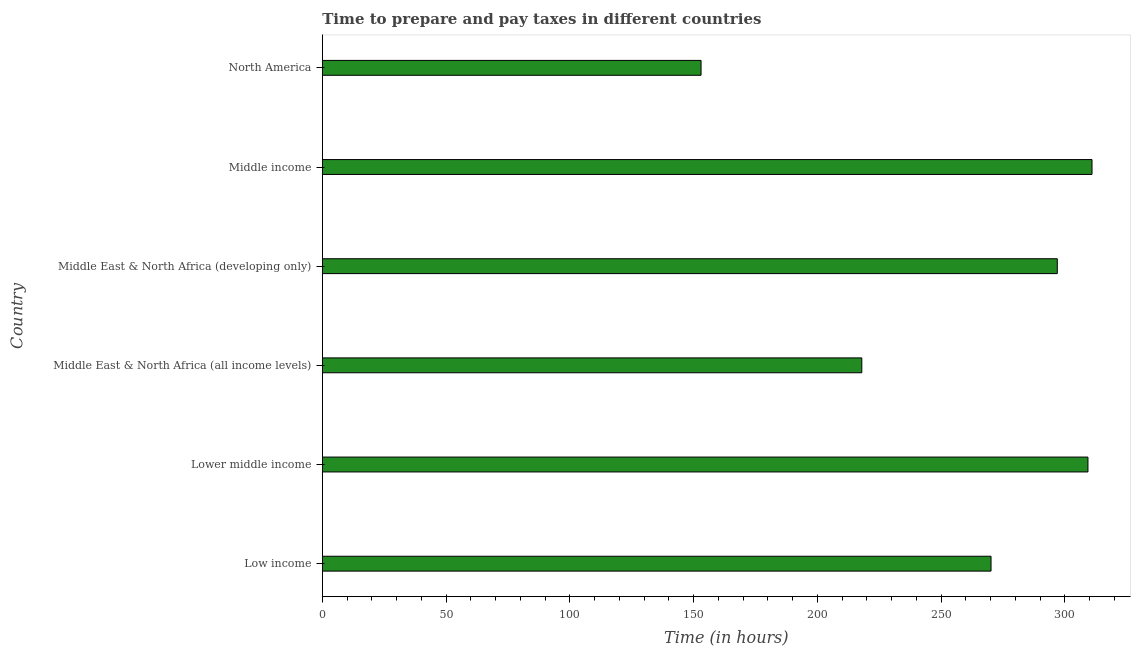What is the title of the graph?
Provide a short and direct response. Time to prepare and pay taxes in different countries. What is the label or title of the X-axis?
Ensure brevity in your answer.  Time (in hours). What is the time to prepare and pay taxes in Lower middle income?
Offer a terse response. 309.31. Across all countries, what is the maximum time to prepare and pay taxes?
Make the answer very short. 310.95. Across all countries, what is the minimum time to prepare and pay taxes?
Your answer should be compact. 153. What is the sum of the time to prepare and pay taxes?
Offer a terse response. 1558.29. What is the difference between the time to prepare and pay taxes in Lower middle income and Middle East & North Africa (all income levels)?
Provide a short and direct response. 91.36. What is the average time to prepare and pay taxes per country?
Provide a succinct answer. 259.71. What is the median time to prepare and pay taxes?
Make the answer very short. 283.54. In how many countries, is the time to prepare and pay taxes greater than 210 hours?
Provide a short and direct response. 5. What is the ratio of the time to prepare and pay taxes in Lower middle income to that in Middle East & North Africa (developing only)?
Keep it short and to the point. 1.04. Is the time to prepare and pay taxes in Middle East & North Africa (all income levels) less than that in Middle income?
Provide a short and direct response. Yes. Is the difference between the time to prepare and pay taxes in Low income and Lower middle income greater than the difference between any two countries?
Your answer should be compact. No. What is the difference between the highest and the second highest time to prepare and pay taxes?
Ensure brevity in your answer.  1.64. Is the sum of the time to prepare and pay taxes in Middle East & North Africa (developing only) and North America greater than the maximum time to prepare and pay taxes across all countries?
Your response must be concise. Yes. What is the difference between the highest and the lowest time to prepare and pay taxes?
Give a very brief answer. 157.95. How many bars are there?
Your answer should be compact. 6. Are all the bars in the graph horizontal?
Offer a very short reply. Yes. What is the Time (in hours) in Low income?
Provide a short and direct response. 270.16. What is the Time (in hours) in Lower middle income?
Ensure brevity in your answer.  309.31. What is the Time (in hours) in Middle East & North Africa (all income levels)?
Give a very brief answer. 217.95. What is the Time (in hours) of Middle East & North Africa (developing only)?
Give a very brief answer. 296.92. What is the Time (in hours) of Middle income?
Your answer should be very brief. 310.95. What is the Time (in hours) in North America?
Offer a very short reply. 153. What is the difference between the Time (in hours) in Low income and Lower middle income?
Offer a terse response. -39.16. What is the difference between the Time (in hours) in Low income and Middle East & North Africa (all income levels)?
Your answer should be very brief. 52.2. What is the difference between the Time (in hours) in Low income and Middle East & North Africa (developing only)?
Your answer should be very brief. -26.77. What is the difference between the Time (in hours) in Low income and Middle income?
Make the answer very short. -40.79. What is the difference between the Time (in hours) in Low income and North America?
Your response must be concise. 117.16. What is the difference between the Time (in hours) in Lower middle income and Middle East & North Africa (all income levels)?
Provide a short and direct response. 91.36. What is the difference between the Time (in hours) in Lower middle income and Middle East & North Africa (developing only)?
Your response must be concise. 12.39. What is the difference between the Time (in hours) in Lower middle income and Middle income?
Offer a terse response. -1.64. What is the difference between the Time (in hours) in Lower middle income and North America?
Offer a terse response. 156.31. What is the difference between the Time (in hours) in Middle East & North Africa (all income levels) and Middle East & North Africa (developing only)?
Ensure brevity in your answer.  -78.97. What is the difference between the Time (in hours) in Middle East & North Africa (all income levels) and Middle income?
Offer a terse response. -93. What is the difference between the Time (in hours) in Middle East & North Africa (all income levels) and North America?
Your answer should be very brief. 64.95. What is the difference between the Time (in hours) in Middle East & North Africa (developing only) and Middle income?
Ensure brevity in your answer.  -14.03. What is the difference between the Time (in hours) in Middle East & North Africa (developing only) and North America?
Your answer should be very brief. 143.92. What is the difference between the Time (in hours) in Middle income and North America?
Give a very brief answer. 157.95. What is the ratio of the Time (in hours) in Low income to that in Lower middle income?
Make the answer very short. 0.87. What is the ratio of the Time (in hours) in Low income to that in Middle East & North Africa (all income levels)?
Provide a short and direct response. 1.24. What is the ratio of the Time (in hours) in Low income to that in Middle East & North Africa (developing only)?
Provide a short and direct response. 0.91. What is the ratio of the Time (in hours) in Low income to that in Middle income?
Your answer should be very brief. 0.87. What is the ratio of the Time (in hours) in Low income to that in North America?
Your answer should be compact. 1.77. What is the ratio of the Time (in hours) in Lower middle income to that in Middle East & North Africa (all income levels)?
Give a very brief answer. 1.42. What is the ratio of the Time (in hours) in Lower middle income to that in Middle East & North Africa (developing only)?
Provide a succinct answer. 1.04. What is the ratio of the Time (in hours) in Lower middle income to that in Middle income?
Ensure brevity in your answer.  0.99. What is the ratio of the Time (in hours) in Lower middle income to that in North America?
Your answer should be very brief. 2.02. What is the ratio of the Time (in hours) in Middle East & North Africa (all income levels) to that in Middle East & North Africa (developing only)?
Provide a succinct answer. 0.73. What is the ratio of the Time (in hours) in Middle East & North Africa (all income levels) to that in Middle income?
Make the answer very short. 0.7. What is the ratio of the Time (in hours) in Middle East & North Africa (all income levels) to that in North America?
Offer a terse response. 1.43. What is the ratio of the Time (in hours) in Middle East & North Africa (developing only) to that in Middle income?
Your answer should be compact. 0.95. What is the ratio of the Time (in hours) in Middle East & North Africa (developing only) to that in North America?
Make the answer very short. 1.94. What is the ratio of the Time (in hours) in Middle income to that in North America?
Keep it short and to the point. 2.03. 